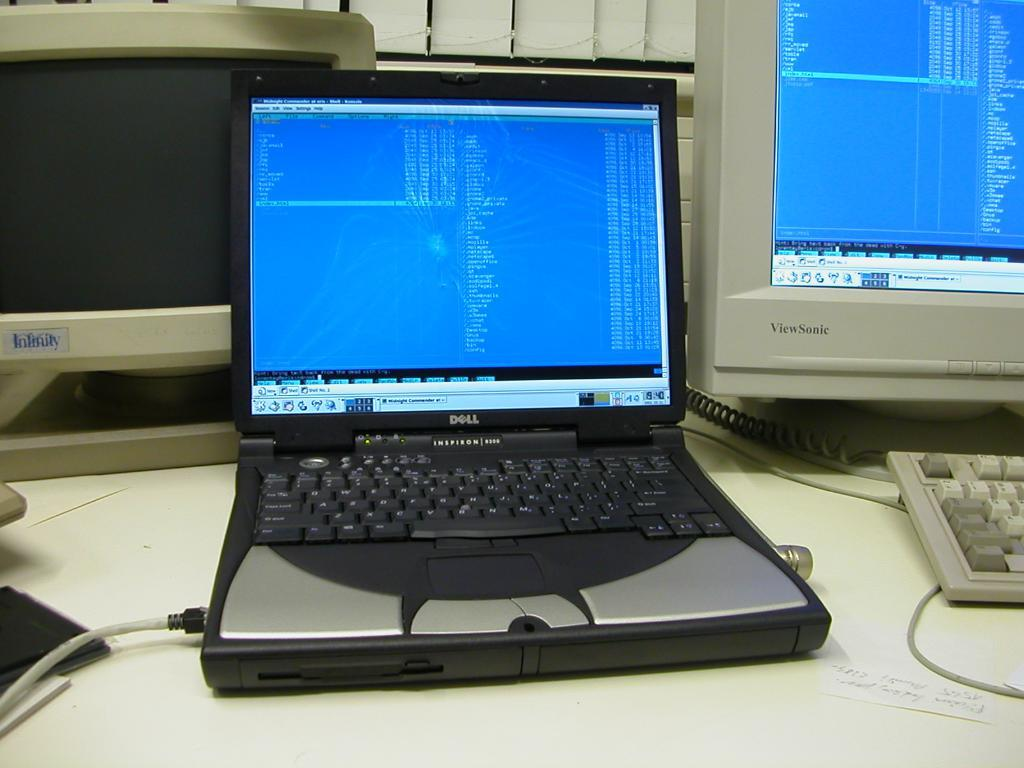What electronic device is visible in the image? There is a laptop in the image. What other electronic devices can be seen in the image? There are monitors and keyboards in the image. Where are the laptop, monitors, and keyboards located? The laptop, monitors, and keyboards are on a table in the image. What might be used to connect the devices in the image? Cable wires are present in the image. What type of flesh can be seen on the plate in the image? There is no plate or flesh present in the image. 